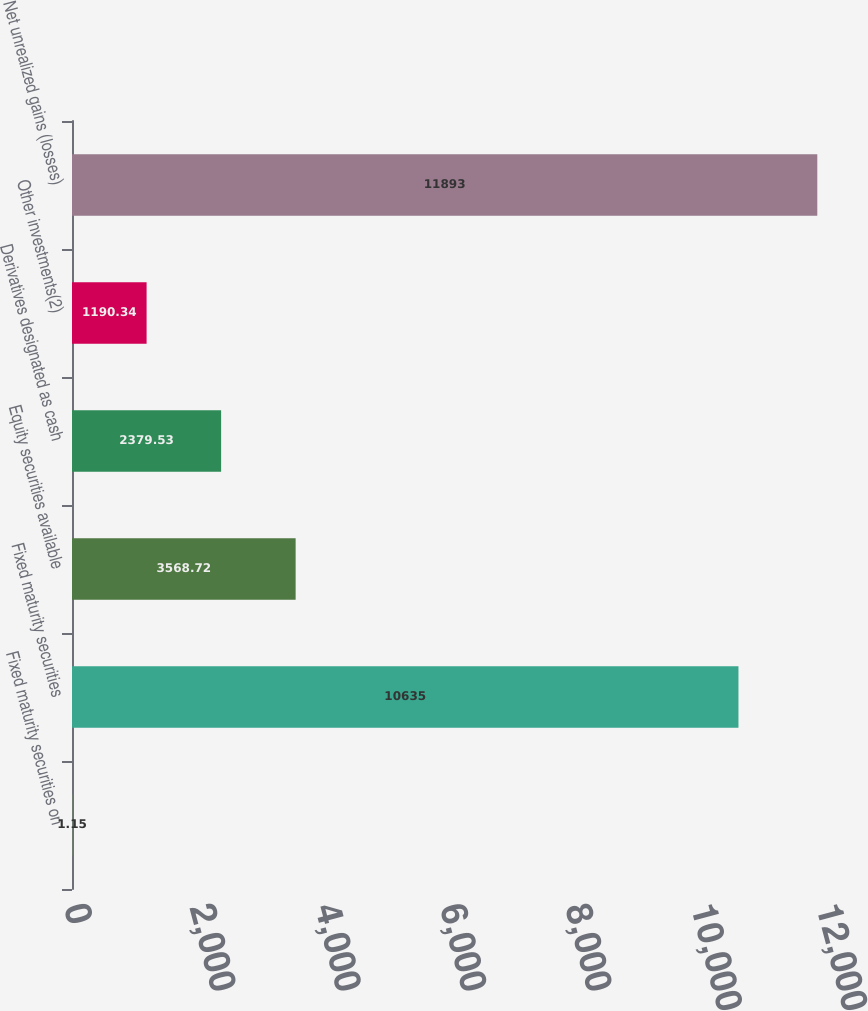<chart> <loc_0><loc_0><loc_500><loc_500><bar_chart><fcel>Fixed maturity securities on<fcel>Fixed maturity securities<fcel>Equity securities available<fcel>Derivatives designated as cash<fcel>Other investments(2)<fcel>Net unrealized gains (losses)<nl><fcel>1.15<fcel>10635<fcel>3568.72<fcel>2379.53<fcel>1190.34<fcel>11893<nl></chart> 